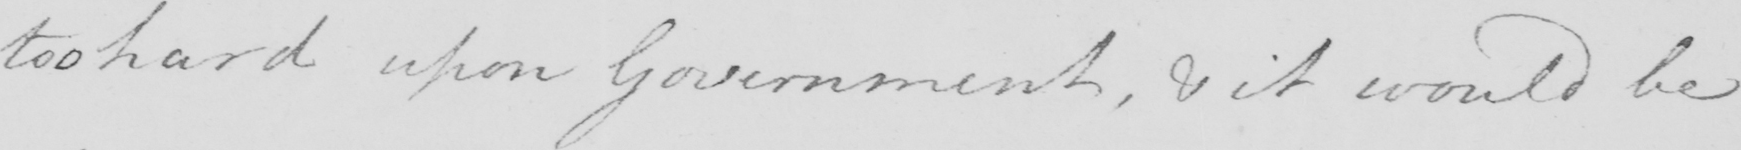What does this handwritten line say? too hard upon Government , & it would be 